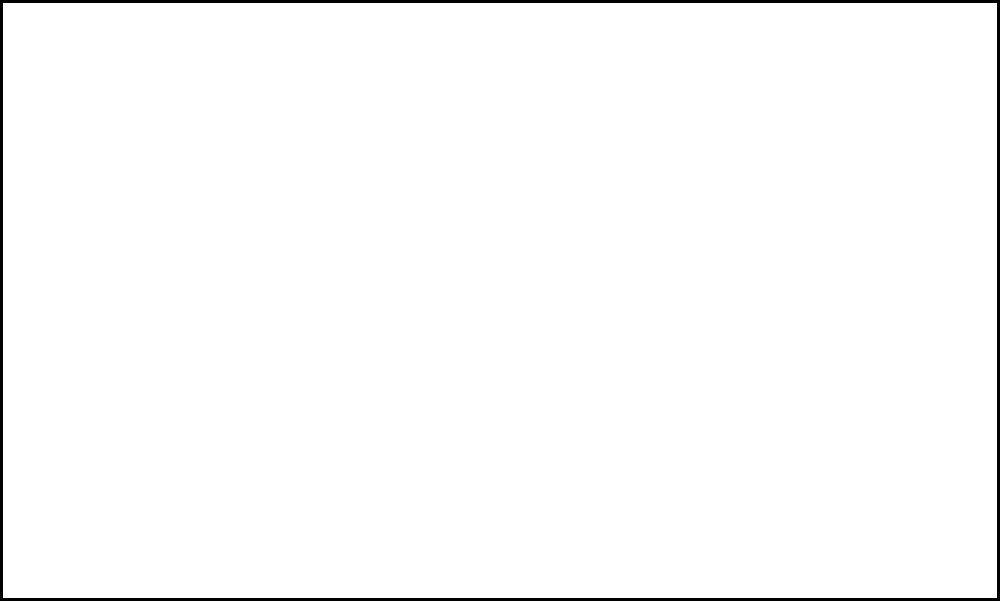As a painter, you're tasked with painting a room with dimensions 5m x 4m x 3m (length x width x height). If one liter of paint covers 10 square meters, how many liters of paint are needed to cover all walls and the ceiling, assuming no windows or doors? To solve this problem, we'll follow these steps:

1. Calculate the total surface area to be painted:
   a. Area of two long walls: $2 \times (5\text{m} \times 3\text{m}) = 30\text{m}^2$
   b. Area of two short walls: $2 \times (4\text{m} \times 3\text{m}) = 24\text{m}^2$
   c. Area of ceiling: $5\text{m} \times 4\text{m} = 20\text{m}^2$
   d. Total area: $30\text{m}^2 + 24\text{m}^2 + 20\text{m}^2 = 74\text{m}^2$

2. Calculate the amount of paint needed:
   - Given: 1 liter covers 10 square meters
   - Paint needed = Total area ÷ Coverage per liter
   - Paint needed = $74\text{m}^2 \div 10\text{m}^2/\text{L} = 7.4\text{L}$

Therefore, 7.4 liters of paint are needed to cover all walls and the ceiling of the room.
Answer: 7.4 liters 